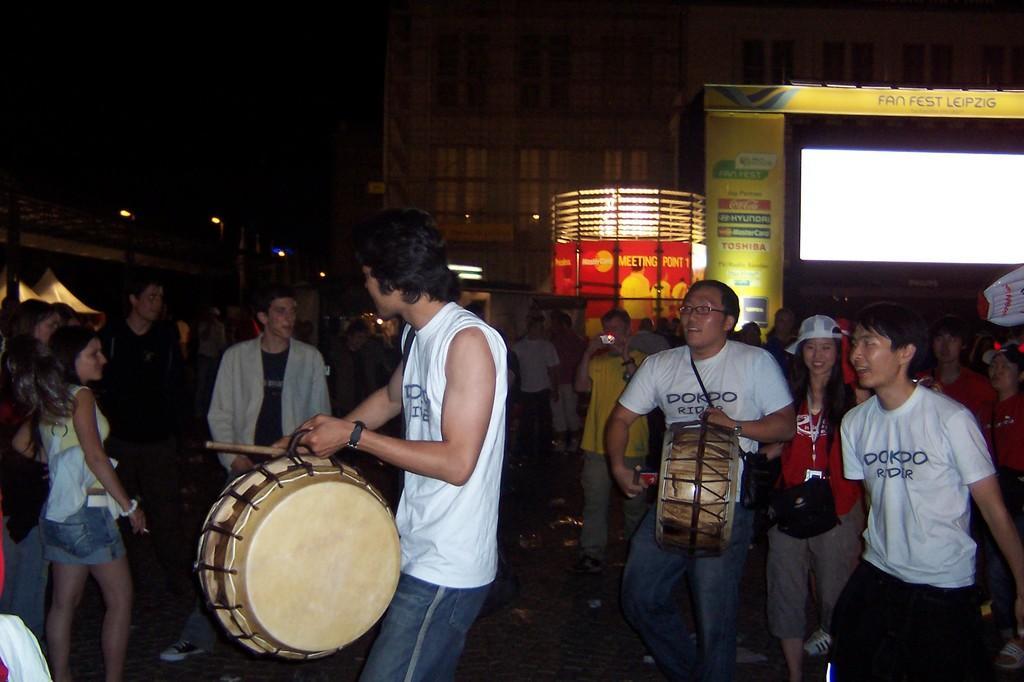Could you give a brief overview of what you see in this image? There are lot of people standing on road and few men are playing drums behind them and there is a stage with lights and at back there is a building. 